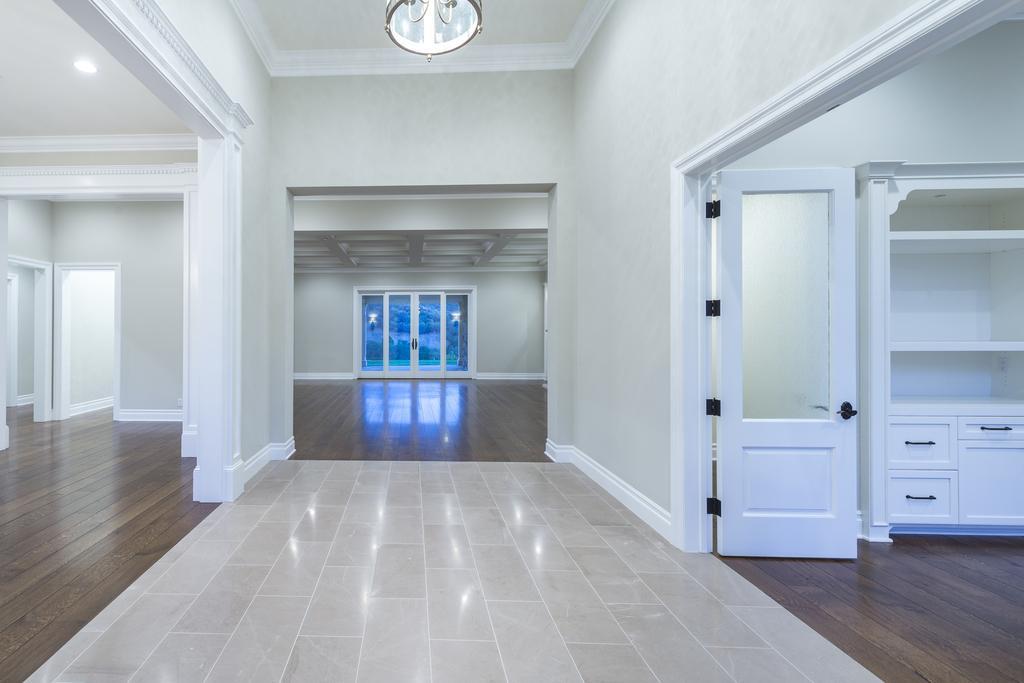In one or two sentences, can you explain what this image depicts? This is a picture of inside of the house, in this picture on the right side there is a door and cupboard. At the bottom there is floor, in the center there are glass windows. On the left side there are doors and wall, at the top there is ceiling and chandelier. 